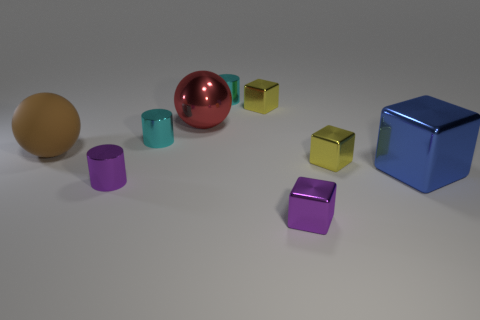Subtract all cyan cylinders. How many were subtracted if there are1cyan cylinders left? 1 Subtract 0 green blocks. How many objects are left? 9 Subtract all spheres. How many objects are left? 7 Subtract 2 cubes. How many cubes are left? 2 Subtract all cyan blocks. Subtract all brown spheres. How many blocks are left? 4 Subtract all red cylinders. How many purple spheres are left? 0 Subtract all rubber objects. Subtract all large blue metallic blocks. How many objects are left? 7 Add 8 large shiny balls. How many large shiny balls are left? 9 Add 8 purple cylinders. How many purple cylinders exist? 9 Add 1 blue things. How many objects exist? 10 